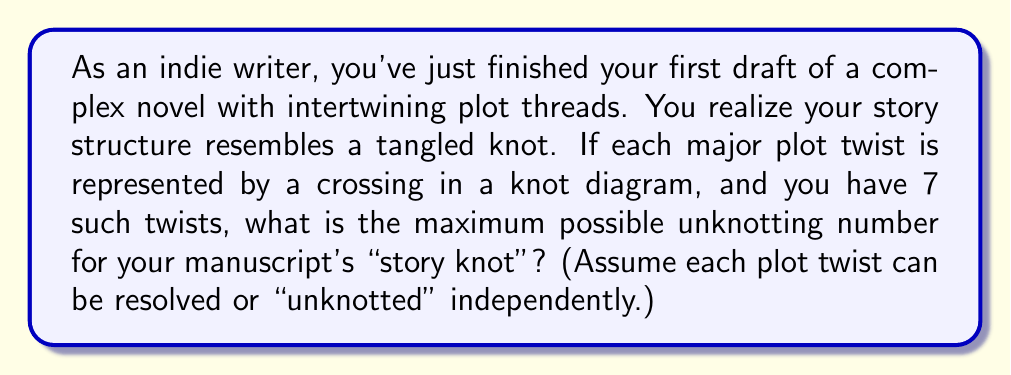Can you solve this math problem? To solve this problem, we need to understand the concept of unknotting number in knot theory and how it relates to editing a manuscript:

1. In knot theory, the unknotting number $u(K)$ of a knot $K$ is the minimum number of crossing changes required to transform the knot into an unknot (a simple loop).

2. In our analogy, each plot twist is a crossing in the knot diagram, and resolving or "unknotting" a plot twist is equivalent to changing a crossing.

3. The maximum unknotting number occurs when every crossing needs to be changed to unknot the knot.

4. Given that we have 7 plot twists (crossings), the maximum unknotting number would be 7.

5. This can be represented mathematically as:

   $$u(K) \leq n$$

   where $n$ is the number of crossings in the knot diagram.

6. In the worst-case scenario, where every plot twist needs major revision:

   $$u(K) = n = 7$$

This maximum unknotting number represents the most challenging editing scenario, where each plot twist requires significant revision to create a coherent, "unknotted" narrative.
Answer: 7 